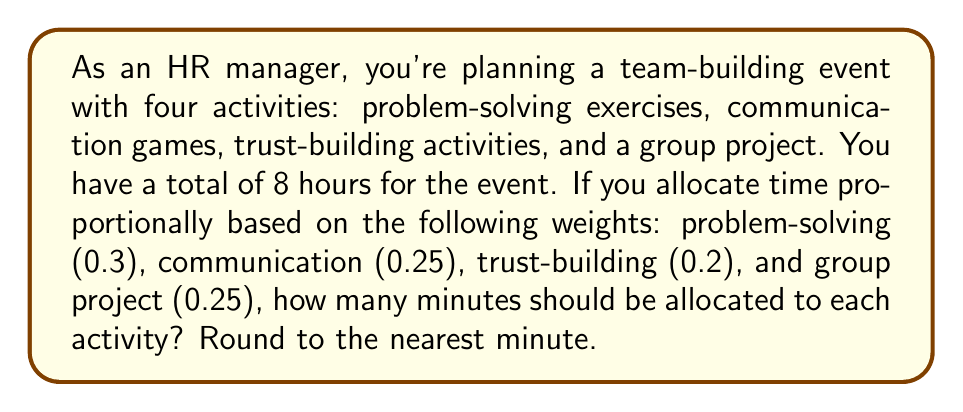Teach me how to tackle this problem. Let's approach this step-by-step:

1) First, we need to convert 8 hours to minutes:
   $8 \text{ hours} \times 60 \text{ minutes/hour} = 480 \text{ minutes}$

2) Now, we need to calculate the total weight:
   $0.3 + 0.25 + 0.2 + 0.25 = 1$

3) For each activity, we'll use the formula:
   $$\text{Time for activity} = \frac{\text{Activity weight}}{\text{Total weight}} \times \text{Total time}$$

4) For problem-solving exercises:
   $$\frac{0.3}{1} \times 480 = 144 \text{ minutes}$$

5) For communication games:
   $$\frac{0.25}{1} \times 480 = 120 \text{ minutes}$$

6) For trust-building activities:
   $$\frac{0.2}{1} \times 480 = 96 \text{ minutes}$$

7) For group project:
   $$\frac{0.25}{1} \times 480 = 120 \text{ minutes}$$

8) Rounding to the nearest minute (which doesn't change any values in this case).
Answer: 144, 120, 96, 120 minutes 